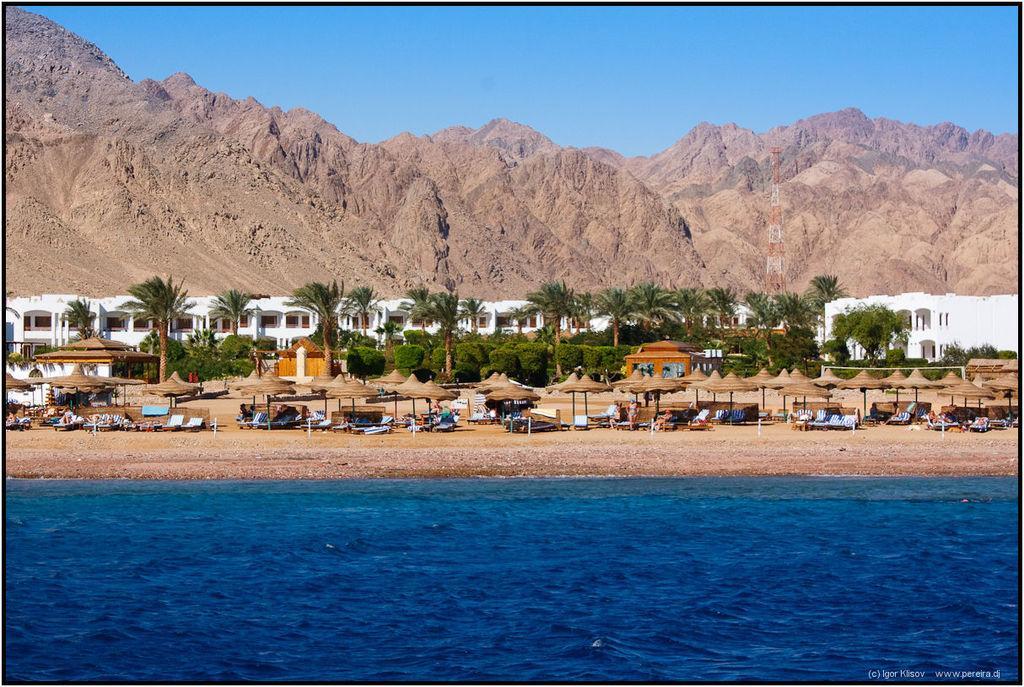Describe this image in one or two sentences. In this image we can see group of chairs and umbrellas are placed on the ground. In the background we can see group of trees ,buildings ,mountains , a tower and the sky. 